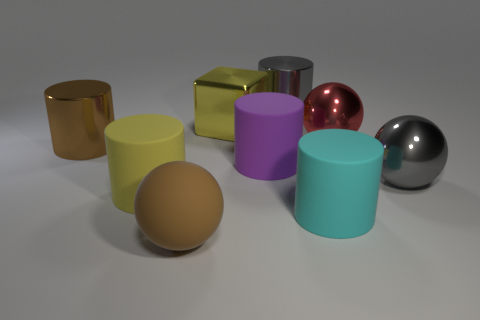There is a large cylinder that is behind the large red ball; what number of large brown matte balls are to the right of it?
Make the answer very short. 0. The object that is both right of the gray metallic cylinder and on the left side of the big red object is made of what material?
Make the answer very short. Rubber. What shape is the cyan thing that is the same size as the brown rubber thing?
Your answer should be very brief. Cylinder. There is a metallic cylinder right of the shiny cylinder in front of the gray shiny thing left of the large cyan matte object; what is its color?
Provide a short and direct response. Gray. What number of objects are either large rubber objects left of the matte sphere or brown metal cylinders?
Your response must be concise. 2. What material is the cyan thing that is the same size as the gray metallic ball?
Your response must be concise. Rubber. What material is the large cylinder on the right side of the metallic cylinder behind the large yellow object that is behind the red ball?
Make the answer very short. Rubber. The large rubber sphere is what color?
Your answer should be very brief. Brown. What number of big things are either cubes or brown metallic cylinders?
Provide a succinct answer. 2. What is the material of the large object that is the same color as the large rubber ball?
Offer a very short reply. Metal. 